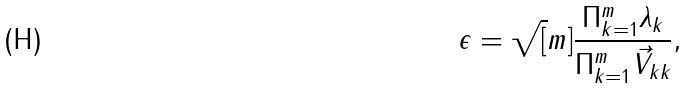<formula> <loc_0><loc_0><loc_500><loc_500>\epsilon = \sqrt { [ } m ] { \frac { \Pi _ { k = 1 } ^ { m } \lambda _ { k } } { \Pi _ { k = 1 } ^ { m } \vec { V } _ { k k } } } ,</formula> 